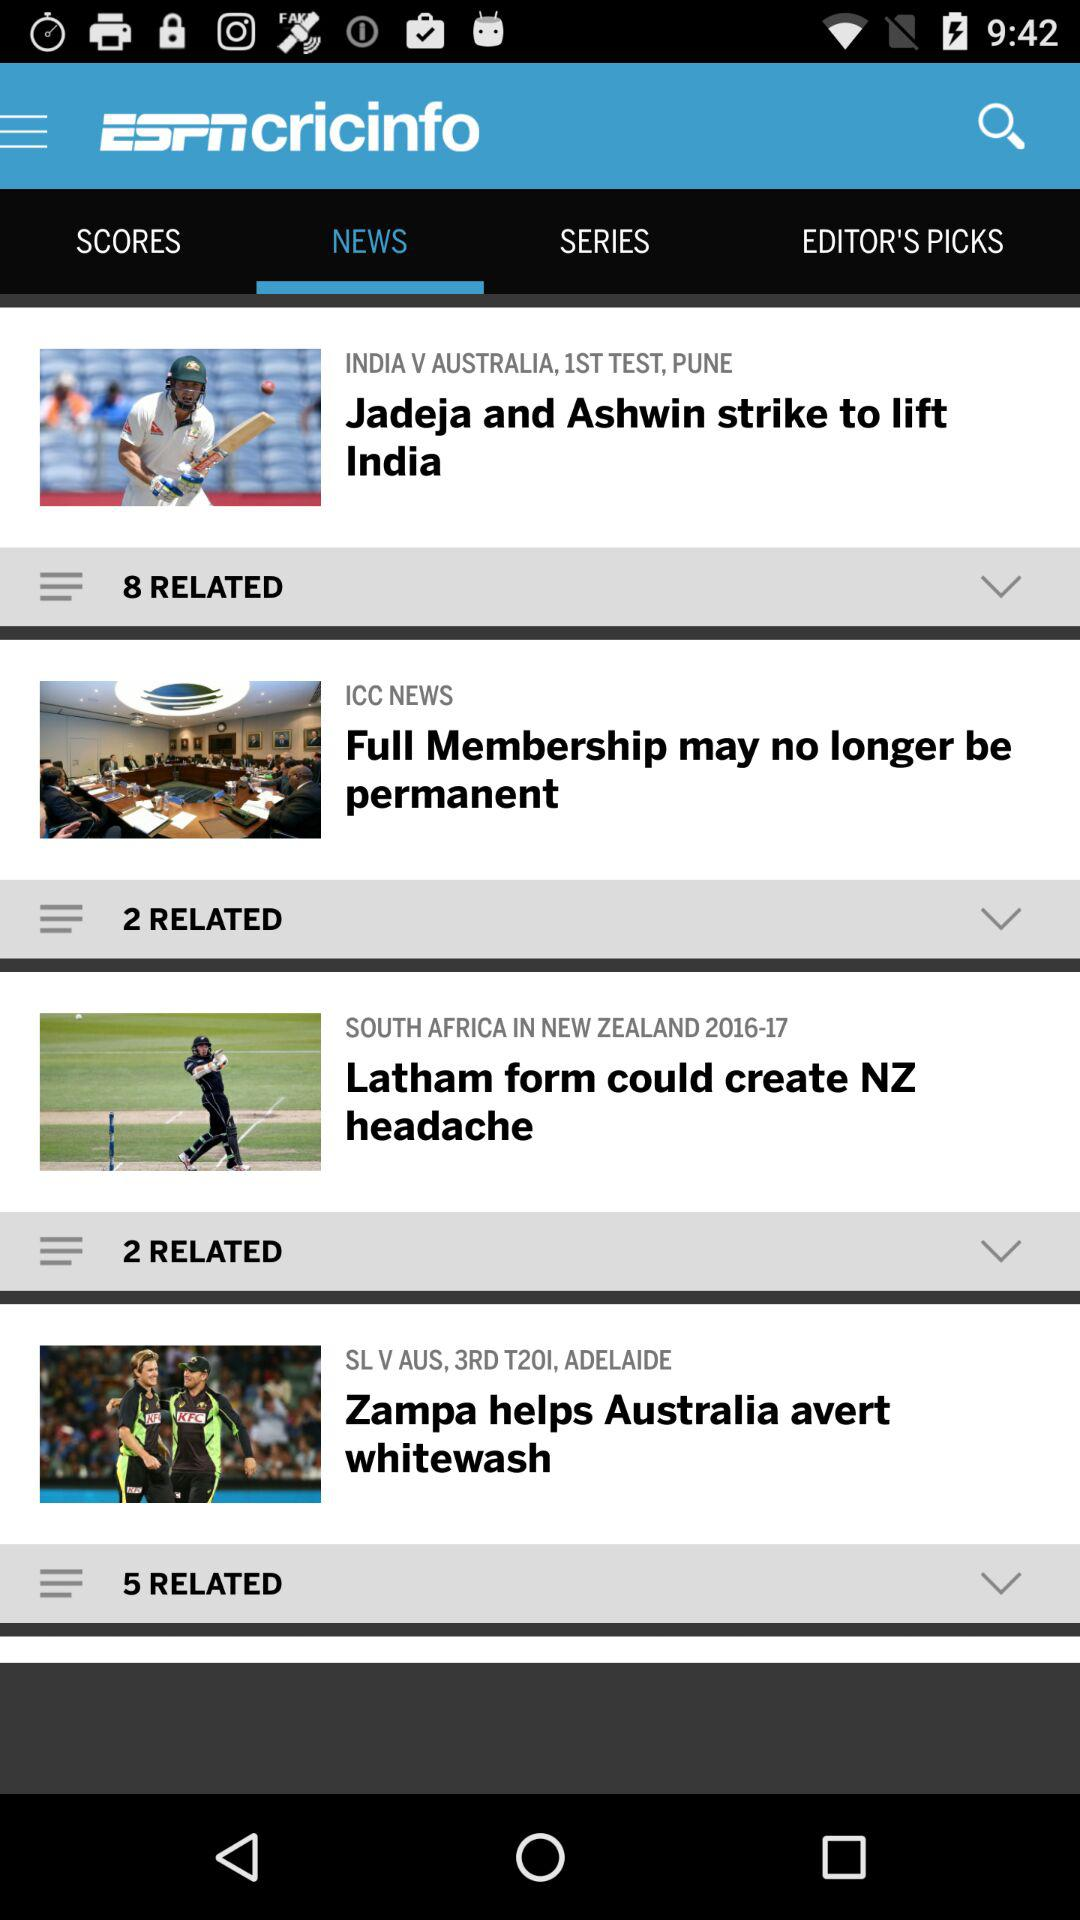Which tab am I on? You are on the "NEWS" tab. 